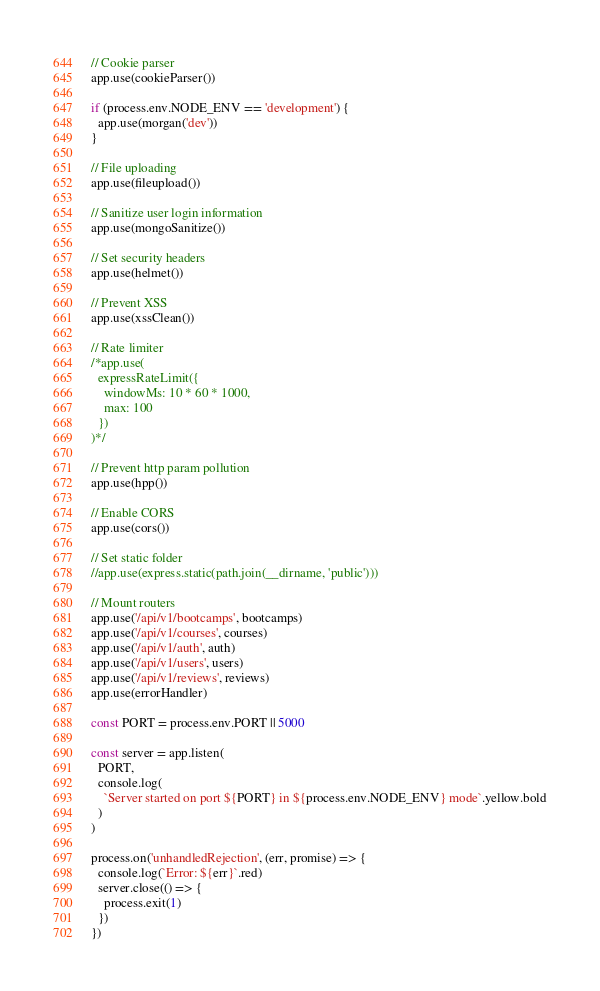Convert code to text. <code><loc_0><loc_0><loc_500><loc_500><_JavaScript_>// Cookie parser
app.use(cookieParser())

if (process.env.NODE_ENV == 'development') {
  app.use(morgan('dev'))
}

// File uploading
app.use(fileupload())

// Sanitize user login information
app.use(mongoSanitize())

// Set security headers
app.use(helmet())

// Prevent XSS
app.use(xssClean())

// Rate limiter
/*app.use(
  expressRateLimit({
    windowMs: 10 * 60 * 1000,
    max: 100
  })
)*/

// Prevent http param pollution
app.use(hpp())

// Enable CORS
app.use(cors())

// Set static folder
//app.use(express.static(path.join(__dirname, 'public')))

// Mount routers
app.use('/api/v1/bootcamps', bootcamps)
app.use('/api/v1/courses', courses)
app.use('/api/v1/auth', auth)
app.use('/api/v1/users', users)
app.use('/api/v1/reviews', reviews)
app.use(errorHandler)

const PORT = process.env.PORT || 5000

const server = app.listen(
  PORT,
  console.log(
    `Server started on port ${PORT} in ${process.env.NODE_ENV} mode`.yellow.bold
  )
)

process.on('unhandledRejection', (err, promise) => {
  console.log(`Error: ${err}`.red)
  server.close(() => {
    process.exit(1)
  })
})
</code> 